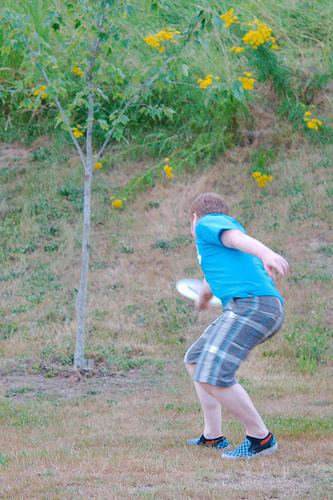Question: where was this photo taken?
Choices:
A. Zoo.
B. In a grassy park.
C. Farm.
D. Field.
Answer with the letter. Answer: B Question: what is he doing?
Choices:
A. Singing.
B. Playing.
C. Sleeping.
D. Drowning.
Answer with the letter. Answer: B 